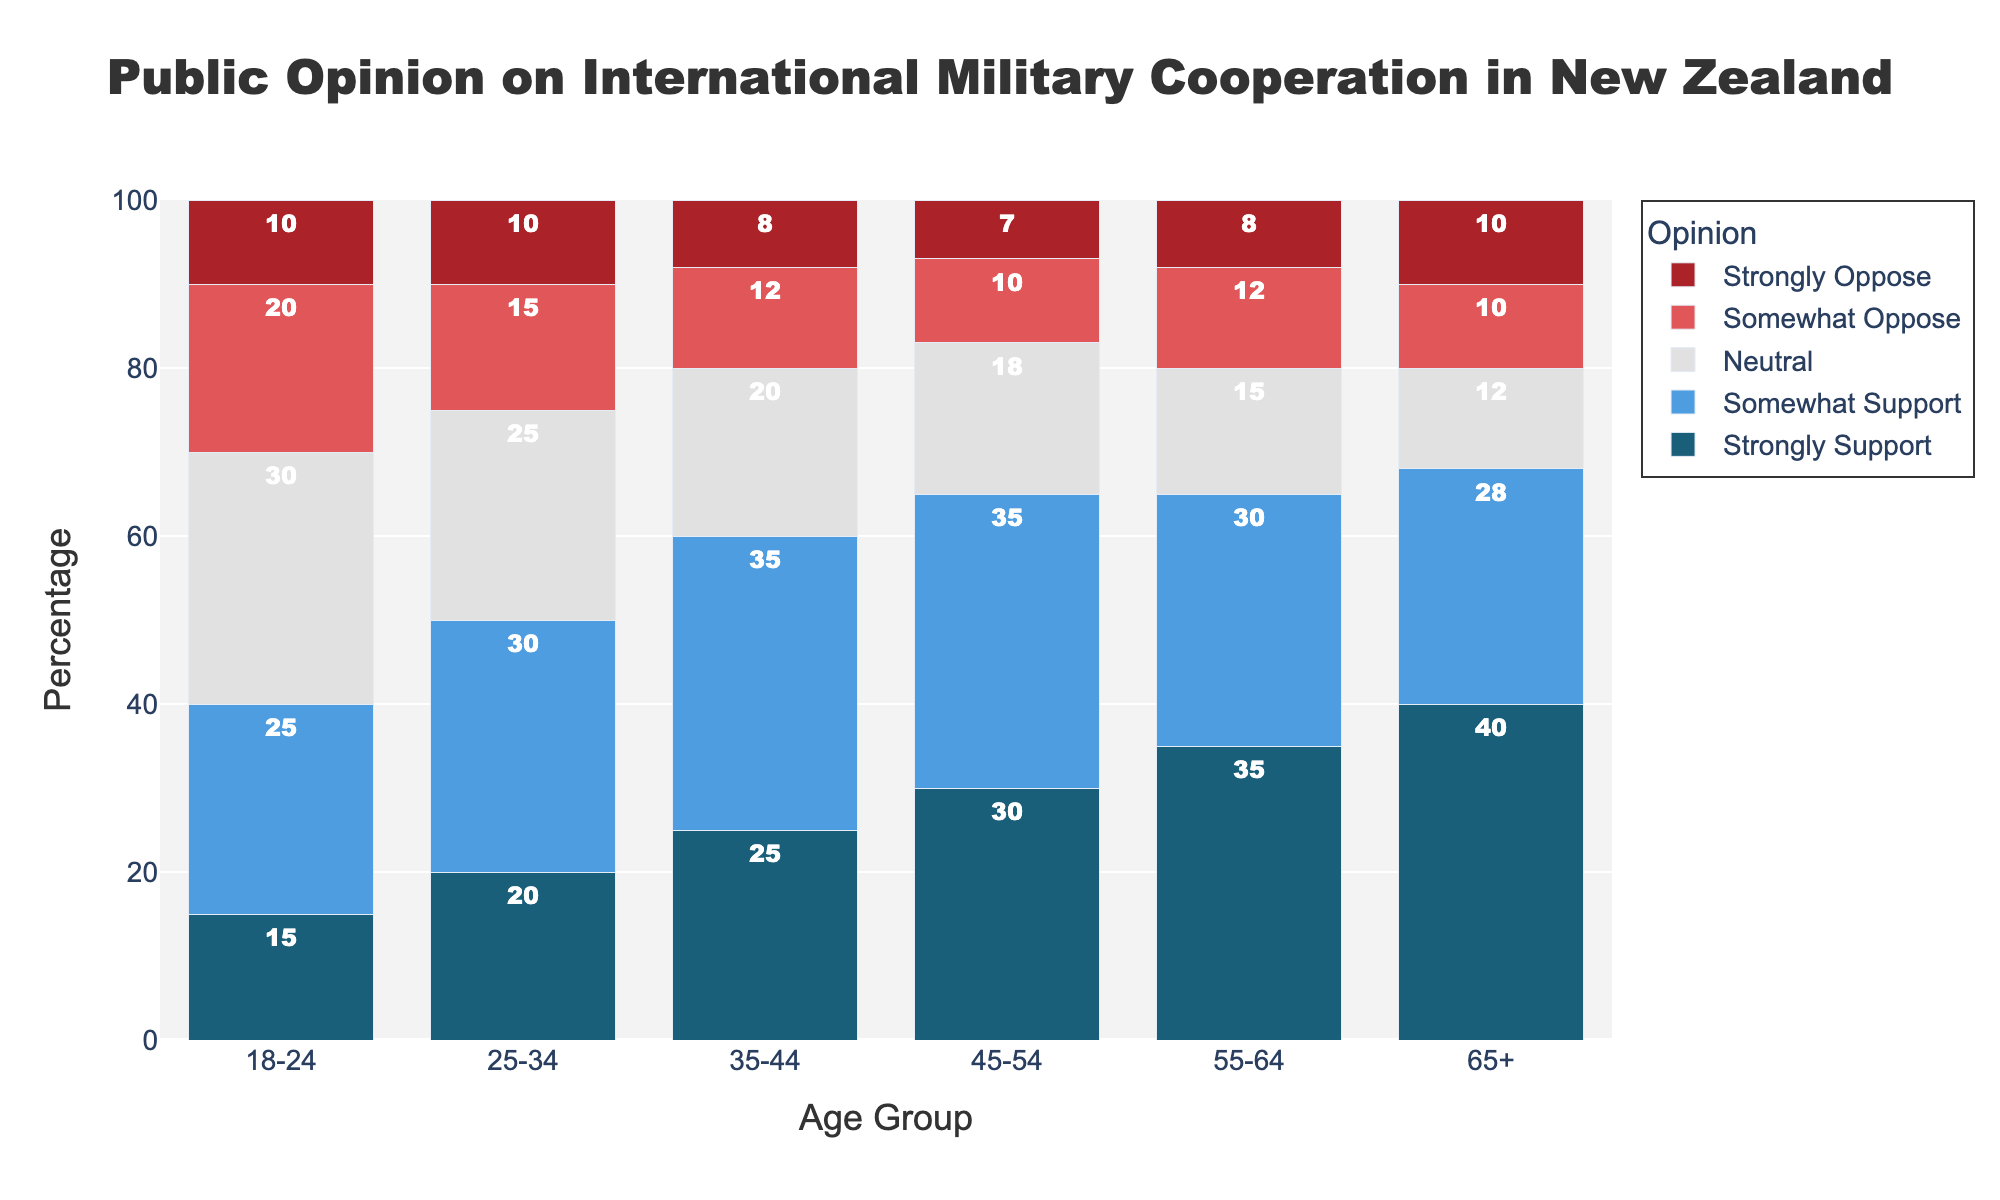Which age group has the highest percentage of "Strongly Support"? Look for the tallest bar in the "Strongly Support" category (dark blue) to find that it's for the 65+ age group.
Answer: 65+ What is the difference in "Neutral" opinions between the 18-24 and 65+ age groups? Subtract the "Neutral" percentage for the 65+ group (12) from the "Neutral" percentage for the 18-24 group (30).
Answer: 18 Which age group shows the largest combined percentage of "Somewhat Oppose" and "Strongly Oppose"? Sum the percentages for "Somewhat Oppose" and "Strongly Oppose" for each age group and identify the largest sum. For example, for the 18-24 group, it is 20 + 10 = 30, and so on. The largest combined percentage is in the 18-24 group with 30.
Answer: 18-24 Compare the percentages of "Somewhat Support" in the 25-34 and 35-44 age groups. Which is higher? Compare the height of the bars in the "Somewhat Support" (light blue) category for the 25-34 (30) and 35-44 (35) age groups.
Answer: 35-44 Which age group has the smallest percentage of "Strongly Oppose"? Look for the shortest bar in the "Strongly Oppose" category (dark red) to find that it's for the 45-54 age group.
Answer: 45-54 What is the total percentage of support ("Strongly Support" and "Somewhat Support") for the 45-54 age group? Add the percentages of "Strongly Support" (30) and "Somewhat Support" (35) for the 45-54 age group.
Answer: 65 Which category has the greatest difference in percentage between the 18-24 and 65+ age groups? Calculate the differences for each category. For "Strongly Support": 40 - 15 = 25, "Somewhat Support": 28 - 25 = 3, "Neutral": 30 - 12 = 18, "Somewhat Oppose": 20 - 10 = 10, "Strongly Oppose": 10 - 10 = 0. The greatest difference is in the "Strongly Support" category with a difference of 25.
Answer: Strongly Support What is the average percentage of "Strongly Support" across all age groups? Sum the "Strongly Support" percentages for all age groups: 15 + 20 + 25 + 30 + 35 + 40 = 165. Then divide by the number of age groups, 6: 165 / 6 = 27.5.
Answer: 27.5 Which age group has the highest percentage of opposition (sum of "Somewhat Oppose" and "Strongly Oppose")? Sum the "Somewhat Oppose" and "Strongly Oppose" percentages for each age group and identify the highest sum. For example, for the 18-24 group, it is 20 + 10 = 30, and repeat for other groups. The highest percentage of opposition is in the 18-24 group with 30.
Answer: 18-24 